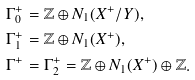Convert formula to latex. <formula><loc_0><loc_0><loc_500><loc_500>& \Gamma _ { 0 } ^ { + } = \mathbb { Z } \oplus N _ { 1 } ( X ^ { + } / Y ) , \\ & \Gamma _ { 1 } ^ { + } = \mathbb { Z } \oplus N _ { 1 } ( X ^ { + } ) , \\ & \Gamma ^ { + } = \Gamma _ { 2 } ^ { + } = \mathbb { Z } \oplus N _ { 1 } ( X ^ { + } ) \oplus \mathbb { Z } .</formula> 